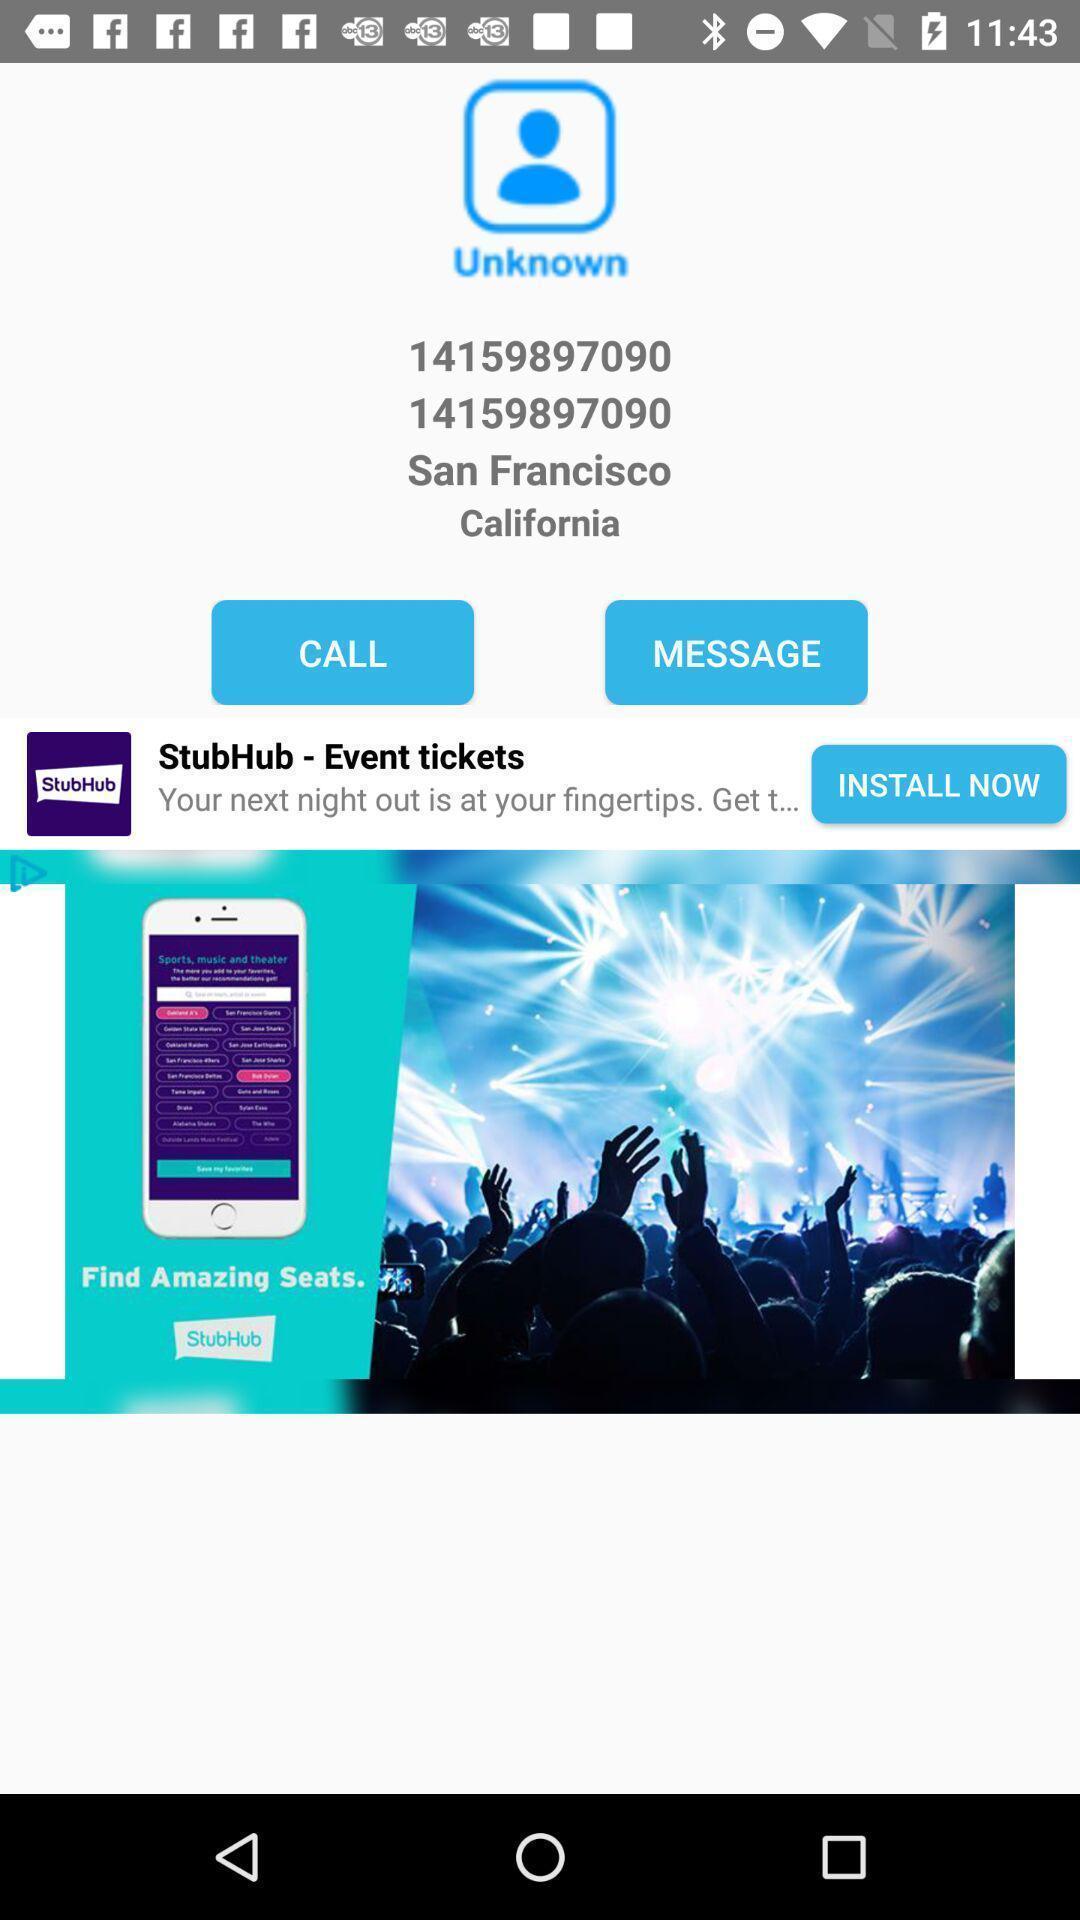Summarize the information in this screenshot. Page showing the unknown contact number. 